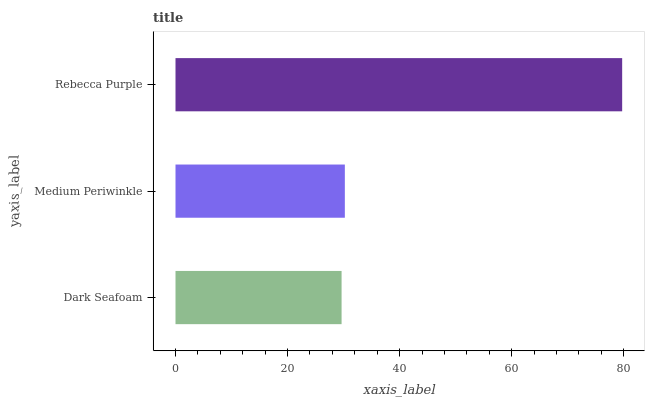Is Dark Seafoam the minimum?
Answer yes or no. Yes. Is Rebecca Purple the maximum?
Answer yes or no. Yes. Is Medium Periwinkle the minimum?
Answer yes or no. No. Is Medium Periwinkle the maximum?
Answer yes or no. No. Is Medium Periwinkle greater than Dark Seafoam?
Answer yes or no. Yes. Is Dark Seafoam less than Medium Periwinkle?
Answer yes or no. Yes. Is Dark Seafoam greater than Medium Periwinkle?
Answer yes or no. No. Is Medium Periwinkle less than Dark Seafoam?
Answer yes or no. No. Is Medium Periwinkle the high median?
Answer yes or no. Yes. Is Medium Periwinkle the low median?
Answer yes or no. Yes. Is Rebecca Purple the high median?
Answer yes or no. No. Is Dark Seafoam the low median?
Answer yes or no. No. 